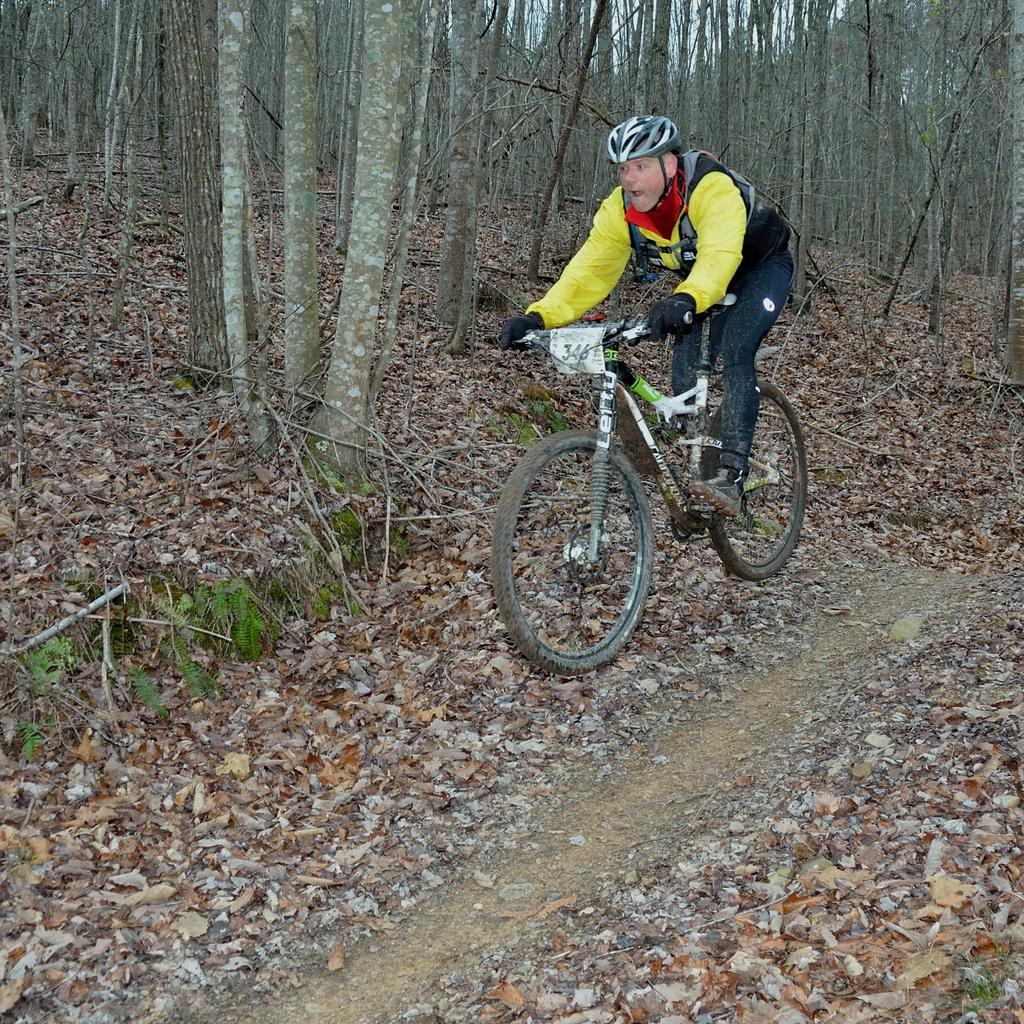How would you summarize this image in a sentence or two? In this image I see a man who is on this cycle and I see numbers on this paper and I see the path on which there are number of leaves. In the background I see number of trees. 